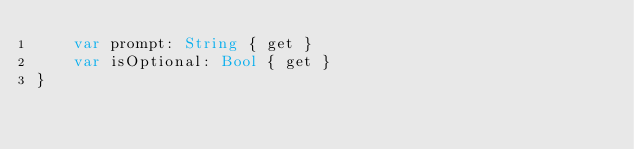Convert code to text. <code><loc_0><loc_0><loc_500><loc_500><_Swift_>    var prompt: String { get }
    var isOptional: Bool { get }
}
</code> 